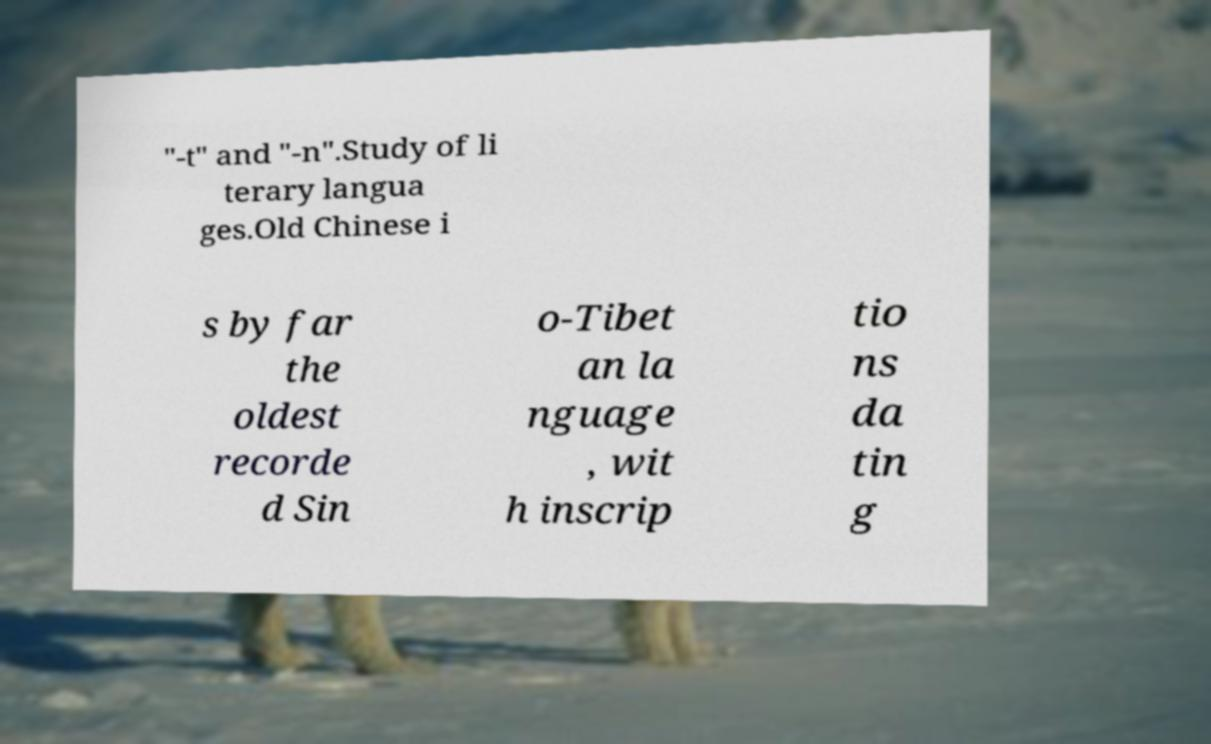Can you accurately transcribe the text from the provided image for me? "-t" and "-n".Study of li terary langua ges.Old Chinese i s by far the oldest recorde d Sin o-Tibet an la nguage , wit h inscrip tio ns da tin g 